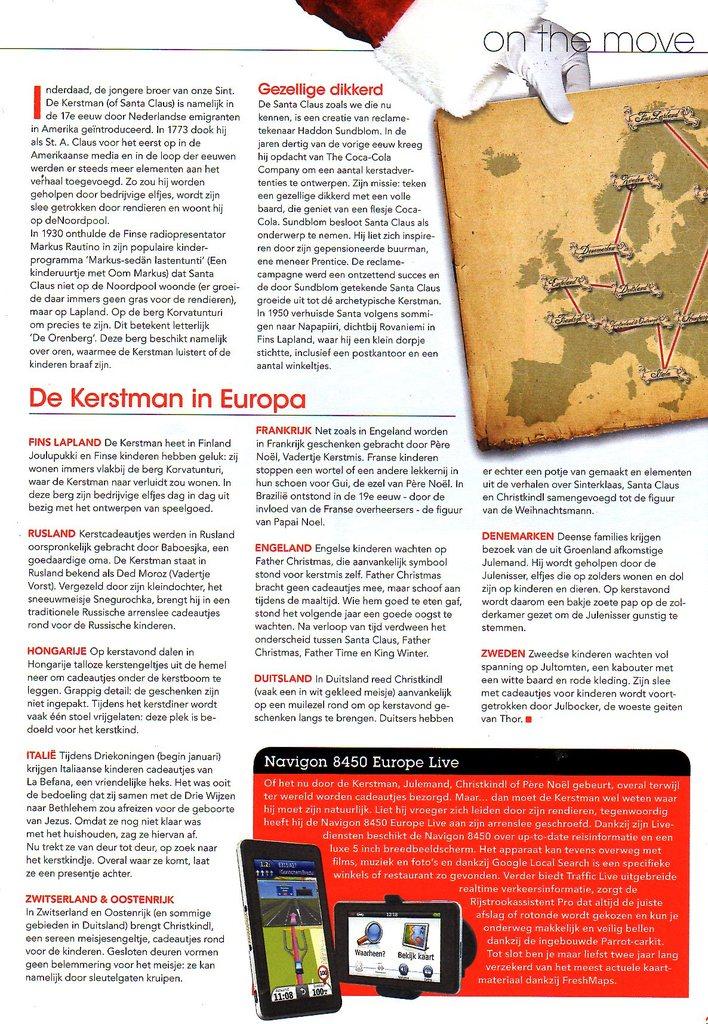What is the title of the page on the top right?
Your response must be concise. On the move. 